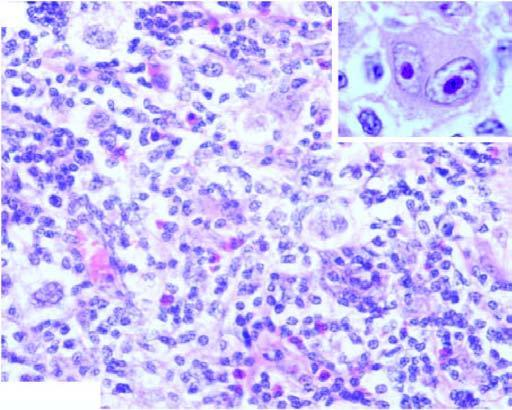what are there?
Answer the question using a single word or phrase. Bands of collagen forming nodules and characteristic lacunar rs cells (inbox in left figure) 